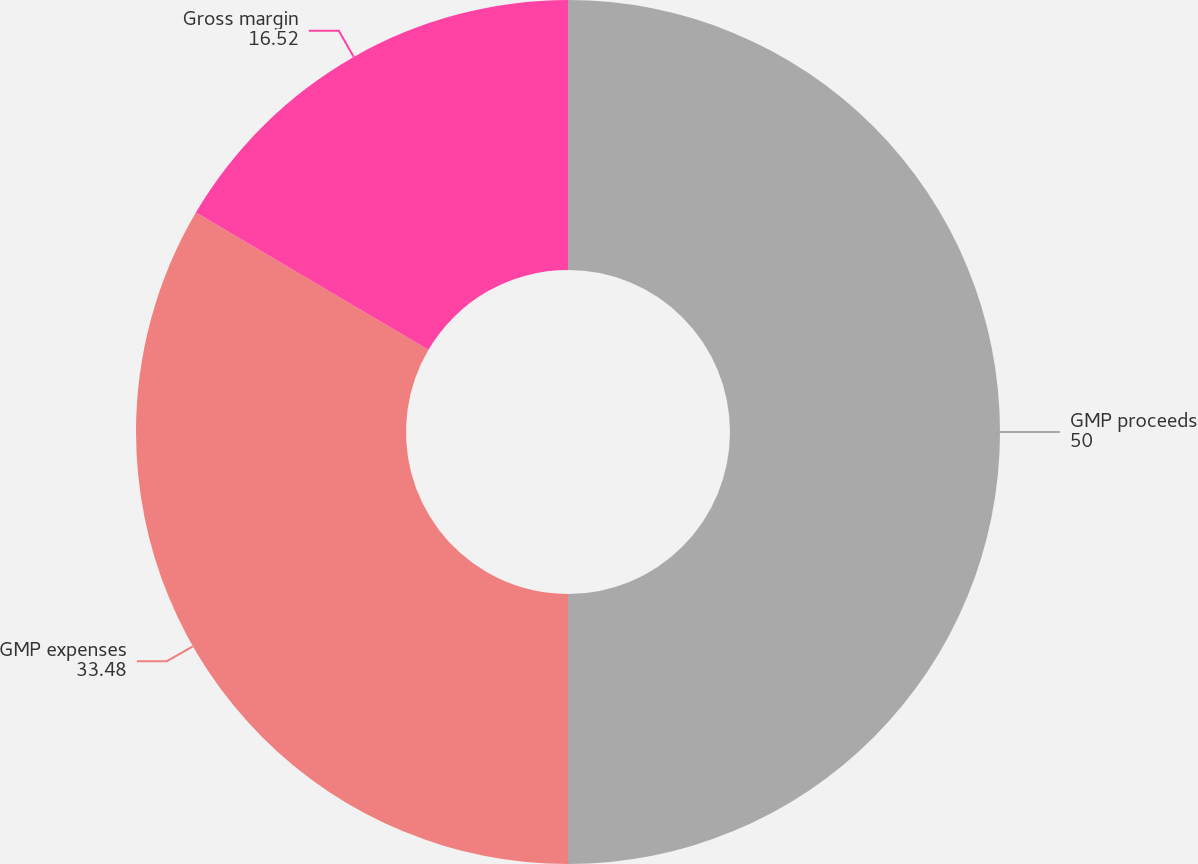Convert chart. <chart><loc_0><loc_0><loc_500><loc_500><pie_chart><fcel>GMP proceeds<fcel>GMP expenses<fcel>Gross margin<nl><fcel>50.0%<fcel>33.48%<fcel>16.52%<nl></chart> 